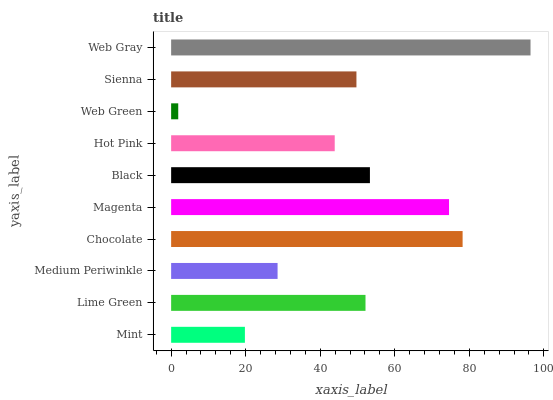Is Web Green the minimum?
Answer yes or no. Yes. Is Web Gray the maximum?
Answer yes or no. Yes. Is Lime Green the minimum?
Answer yes or no. No. Is Lime Green the maximum?
Answer yes or no. No. Is Lime Green greater than Mint?
Answer yes or no. Yes. Is Mint less than Lime Green?
Answer yes or no. Yes. Is Mint greater than Lime Green?
Answer yes or no. No. Is Lime Green less than Mint?
Answer yes or no. No. Is Lime Green the high median?
Answer yes or no. Yes. Is Sienna the low median?
Answer yes or no. Yes. Is Black the high median?
Answer yes or no. No. Is Magenta the low median?
Answer yes or no. No. 